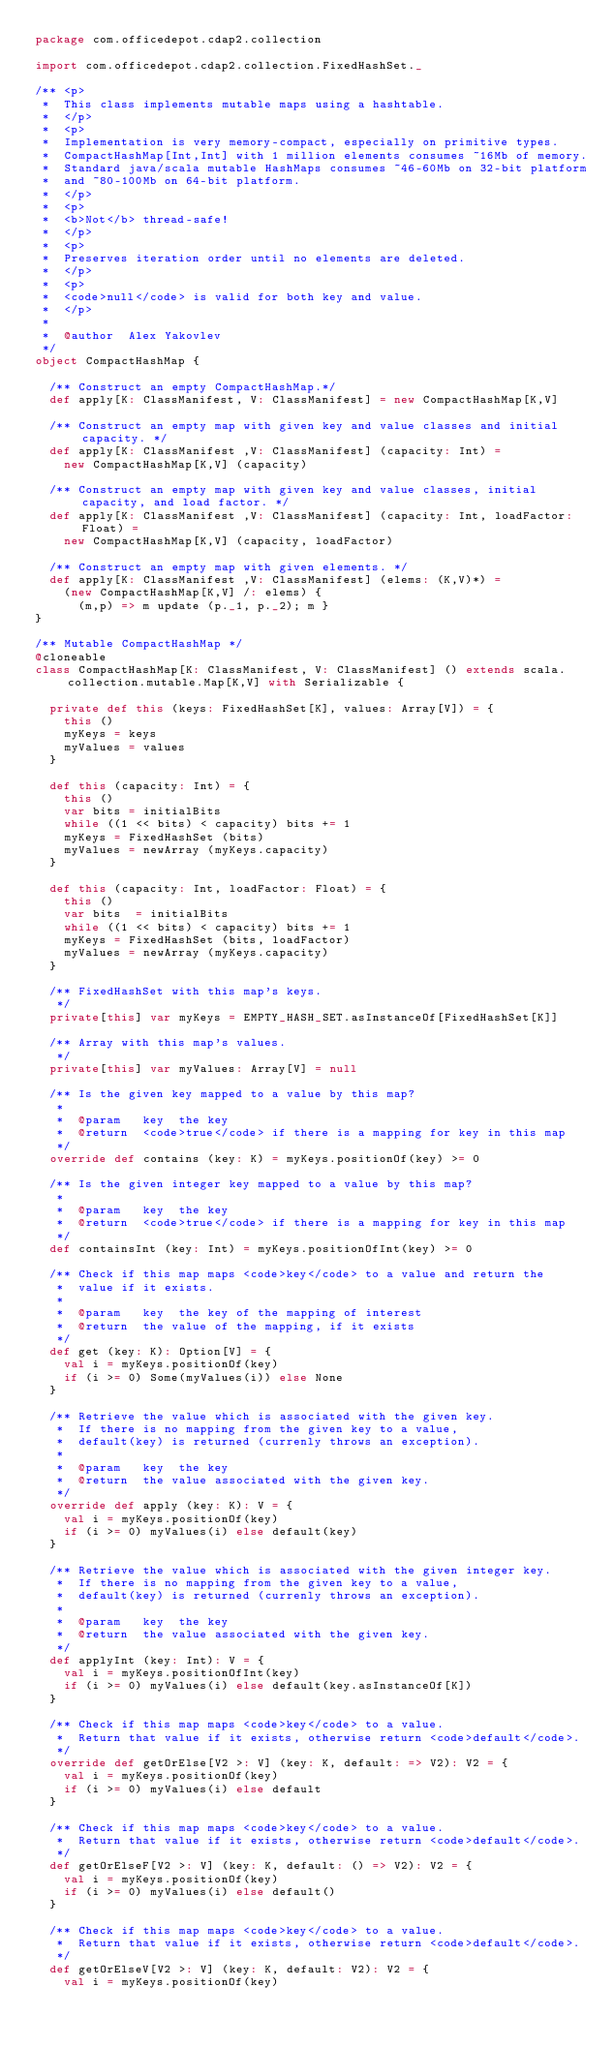Convert code to text. <code><loc_0><loc_0><loc_500><loc_500><_Scala_>package com.officedepot.cdap2.collection

import com.officedepot.cdap2.collection.FixedHashSet._

/** <p>
 *  This class implements mutable maps using a hashtable.
 *  </p>
 *  <p>
 *  Implementation is very memory-compact, especially on primitive types.
 *  CompactHashMap[Int,Int] with 1 million elements consumes ~16Mb of memory.
 *  Standard java/scala mutable HashMaps consumes ~46-60Mb on 32-bit platform
 *  and ~80-100Mb on 64-bit platform.
 *  </p>
 *  <p>
 *  <b>Not</b> thread-safe!
 *  </p>
 *  <p>
 *  Preserves iteration order until no elements are deleted.
 *  </p>
 *  <p>
 *  <code>null</code> is valid for both key and value.
 *  </p>
 *
 *  @author  Alex Yakovlev
 */
object CompactHashMap {

  /** Construct an empty CompactHashMap.*/
  def apply[K: ClassManifest, V: ClassManifest] = new CompactHashMap[K,V]

  /** Construct an empty map with given key and value classes and initial capacity. */
  def apply[K: ClassManifest ,V: ClassManifest] (capacity: Int) =
    new CompactHashMap[K,V] (capacity)

  /** Construct an empty map with given key and value classes, initial capacity, and load factor. */
  def apply[K: ClassManifest ,V: ClassManifest] (capacity: Int, loadFactor: Float) =
    new CompactHashMap[K,V] (capacity, loadFactor)

  /** Construct an empty map with given elements. */
  def apply[K: ClassManifest ,V: ClassManifest] (elems: (K,V)*) =
    (new CompactHashMap[K,V] /: elems) {
      (m,p) => m update (p._1, p._2); m }
}

/** Mutable CompactHashMap */
@cloneable
class CompactHashMap[K: ClassManifest, V: ClassManifest] () extends scala.collection.mutable.Map[K,V] with Serializable {

  private def this (keys: FixedHashSet[K], values: Array[V]) = {
    this ()
    myKeys = keys
    myValues = values
  }

  def this (capacity: Int) = {
    this ()
    var bits = initialBits
    while ((1 << bits) < capacity) bits += 1
    myKeys = FixedHashSet (bits)
    myValues = newArray (myKeys.capacity)
  }

  def this (capacity: Int, loadFactor: Float) = {
    this ()
    var bits  = initialBits
    while ((1 << bits) < capacity) bits += 1
    myKeys = FixedHashSet (bits, loadFactor)
    myValues = newArray (myKeys.capacity)
  }

  /** FixedHashSet with this map's keys.
   */
  private[this] var myKeys = EMPTY_HASH_SET.asInstanceOf[FixedHashSet[K]]

  /** Array with this map's values.
   */
  private[this] var myValues: Array[V] = null

  /** Is the given key mapped to a value by this map?
   *
   *  @param   key  the key
   *  @return  <code>true</code> if there is a mapping for key in this map
   */
  override def contains (key: K) = myKeys.positionOf(key) >= 0

  /** Is the given integer key mapped to a value by this map?
   *
   *  @param   key  the key
   *  @return  <code>true</code> if there is a mapping for key in this map
   */
  def containsInt (key: Int) = myKeys.positionOfInt(key) >= 0

  /** Check if this map maps <code>key</code> to a value and return the
   *  value if it exists.
   *
   *  @param   key  the key of the mapping of interest
   *  @return  the value of the mapping, if it exists
   */
  def get (key: K): Option[V] = {
    val i = myKeys.positionOf(key)
    if (i >= 0) Some(myValues(i)) else None
  }

  /** Retrieve the value which is associated with the given key.
   *  If there is no mapping from the given key to a value,
   *  default(key) is returned (currenly throws an exception).
   *
   *  @param   key  the key
   *  @return  the value associated with the given key.
   */
  override def apply (key: K): V = {
    val i = myKeys.positionOf(key)
    if (i >= 0) myValues(i) else default(key)
  }

  /** Retrieve the value which is associated with the given integer key.
   *  If there is no mapping from the given key to a value,
   *  default(key) is returned (currenly throws an exception).
   *
   *  @param   key  the key
   *  @return  the value associated with the given key.
   */
  def applyInt (key: Int): V = {
    val i = myKeys.positionOfInt(key)
    if (i >= 0) myValues(i) else default(key.asInstanceOf[K])
  }

  /** Check if this map maps <code>key</code> to a value.
   *  Return that value if it exists, otherwise return <code>default</code>.
   */
  override def getOrElse[V2 >: V] (key: K, default: => V2): V2 = {
    val i = myKeys.positionOf(key)
    if (i >= 0) myValues(i) else default
  }

  /** Check if this map maps <code>key</code> to a value.
   *  Return that value if it exists, otherwise return <code>default</code>.
   */
  def getOrElseF[V2 >: V] (key: K, default: () => V2): V2 = {
    val i = myKeys.positionOf(key)
    if (i >= 0) myValues(i) else default()
  }

  /** Check if this map maps <code>key</code> to a value.
   *  Return that value if it exists, otherwise return <code>default</code>.
   */
  def getOrElseV[V2 >: V] (key: K, default: V2): V2 = {
    val i = myKeys.positionOf(key)</code> 